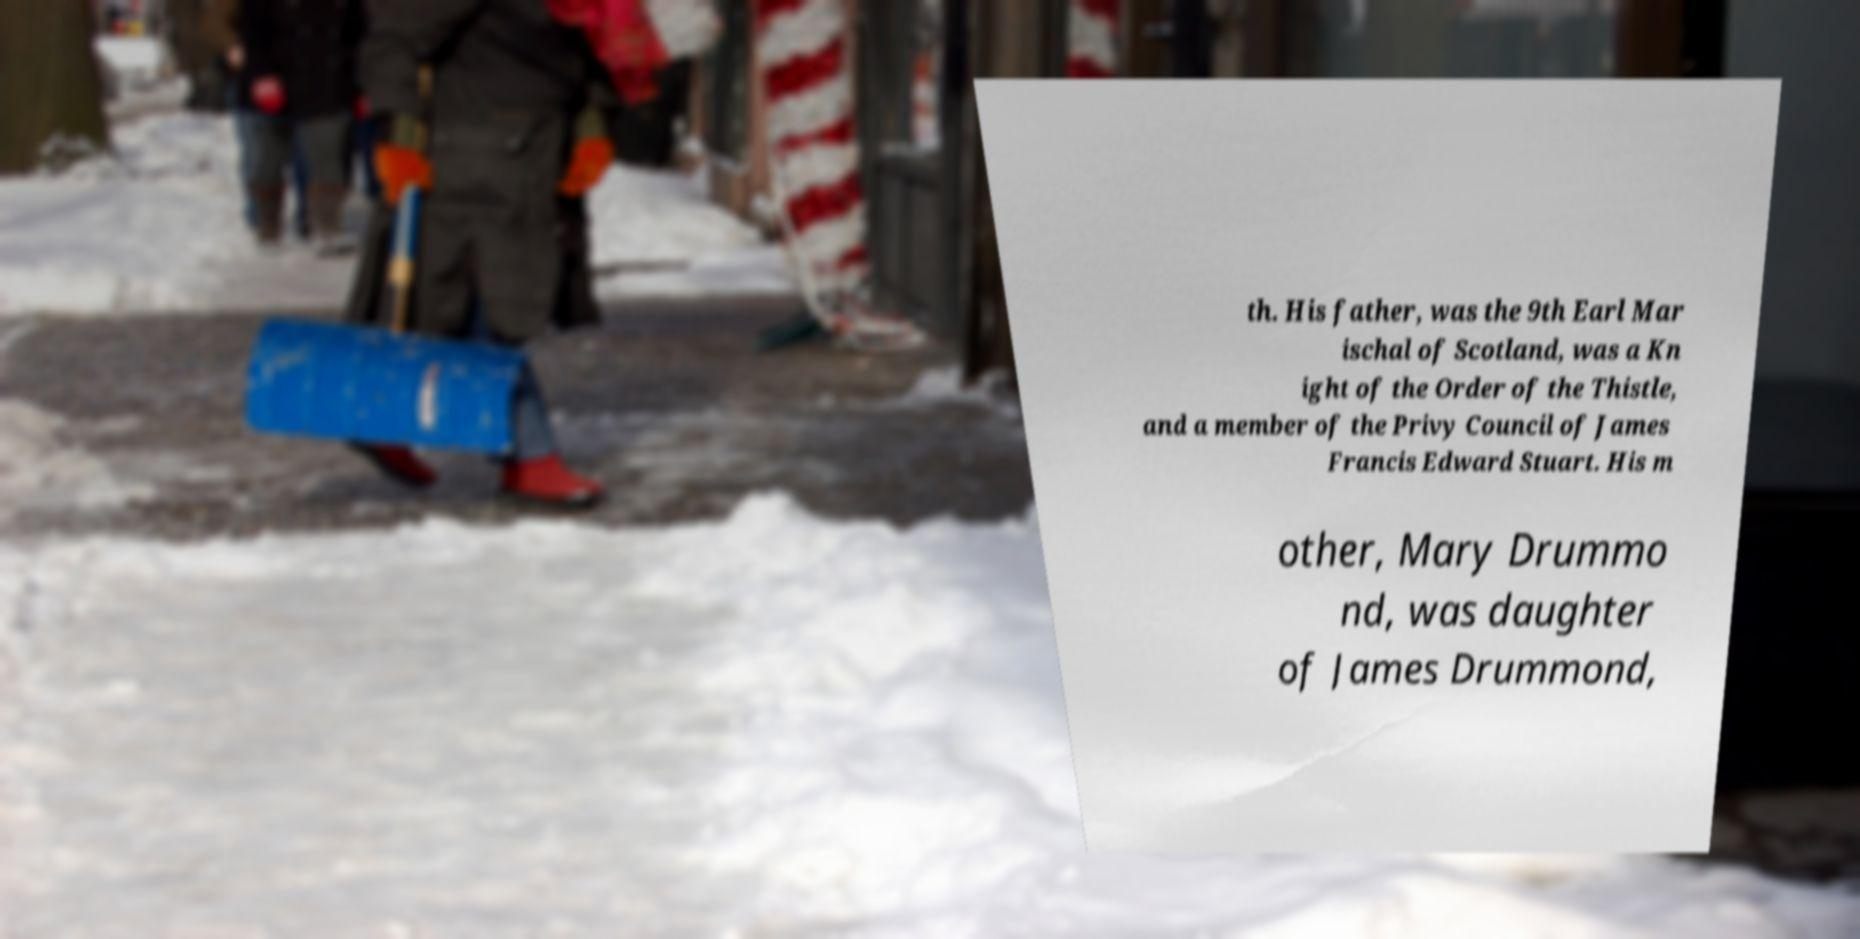I need the written content from this picture converted into text. Can you do that? th. His father, was the 9th Earl Mar ischal of Scotland, was a Kn ight of the Order of the Thistle, and a member of the Privy Council of James Francis Edward Stuart. His m other, Mary Drummo nd, was daughter of James Drummond, 